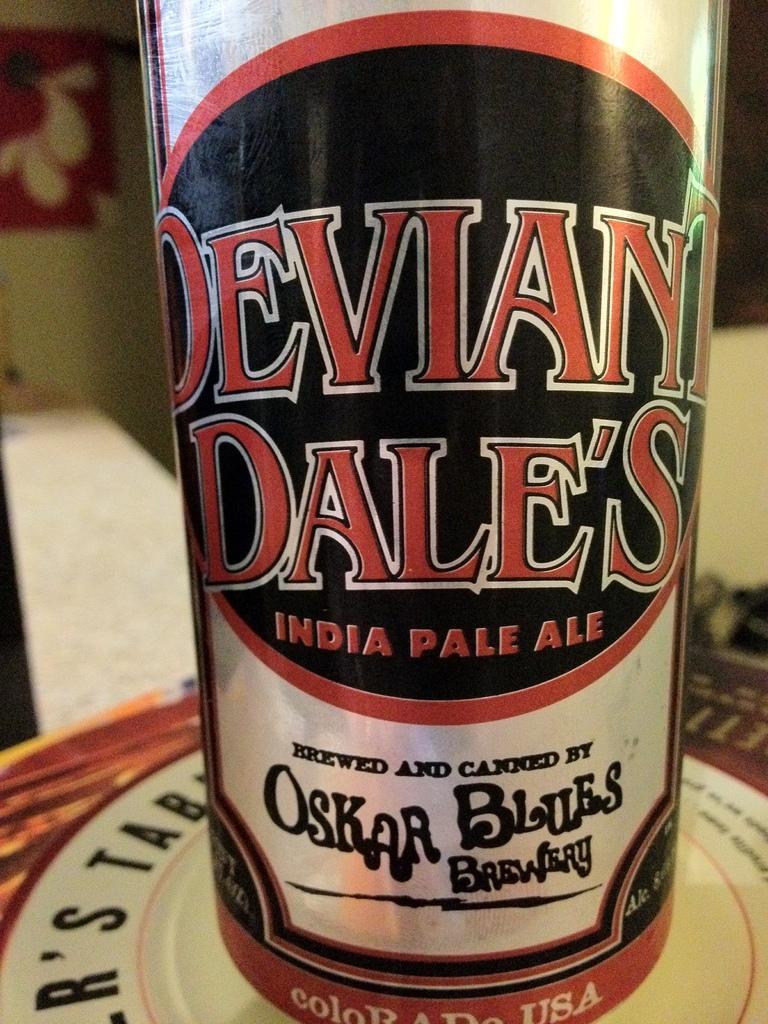How would you summarize this image in a sentence or two? In this picture, it looks like a bottle which is covered by a label and the bottle is on an object. Behind the bottle there is the blurred background. 